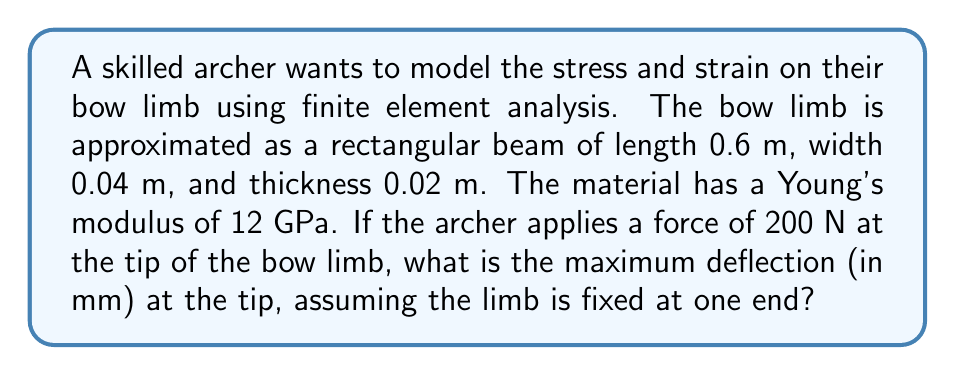Help me with this question. To solve this problem, we'll use the finite element method to approximate the deflection of the bow limb. We'll model the limb as a cantilever beam with a point load at the free end.

Step 1: Define the beam properties
Length (L) = 0.6 m
Width (w) = 0.04 m
Thickness (t) = 0.02 m
Young's modulus (E) = 12 GPa = 12 × 10^9 Pa
Force (F) = 200 N

Step 2: Calculate the moment of inertia (I) for a rectangular cross-section
$$I = \frac{wt^3}{12} = \frac{0.04 \times 0.02^3}{12} = 2.67 \times 10^{-8} m^4$$

Step 3: Use the beam deflection formula for a cantilever beam with a point load at the free end
The maximum deflection occurs at the tip and is given by:
$$\delta_{max} = \frac{FL^3}{3EI}$$

Step 4: Substitute the values into the equation
$$\delta_{max} = \frac{200 \times 0.6^3}{3 \times 12 \times 10^9 \times 2.67 \times 10^{-8}}$$

Step 5: Calculate the result
$$\delta_{max} = 0.008955 m = 8.955 mm$$

Therefore, the maximum deflection at the tip of the bow limb is approximately 8.955 mm.
Answer: 8.955 mm 